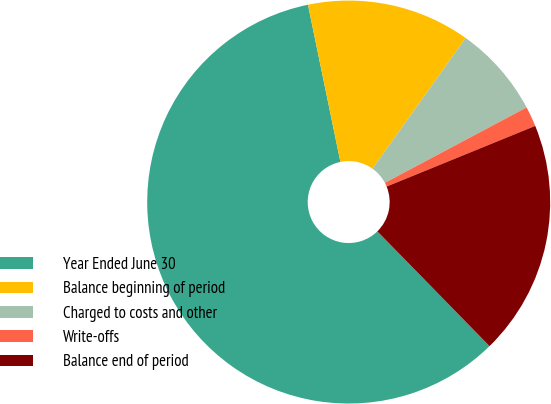Convert chart. <chart><loc_0><loc_0><loc_500><loc_500><pie_chart><fcel>Year Ended June 30<fcel>Balance beginning of period<fcel>Charged to costs and other<fcel>Write-offs<fcel>Balance end of period<nl><fcel>59.08%<fcel>13.1%<fcel>7.36%<fcel>1.61%<fcel>18.85%<nl></chart> 